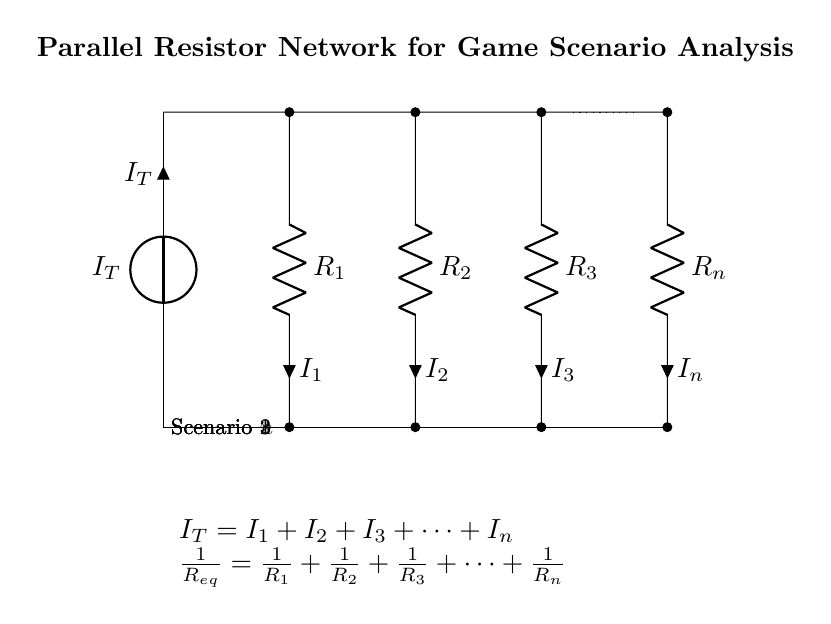What is the total current entering the circuit? The total current \( I_T \) is the sum of the currents through all parallel branches, represented by the equation \( I_T = I_1 + I_2 + I_3 + \cdots + I_n \).
Answer: Total current \( I_T \) What is the equivalent resistance of this parallel network? The equivalent resistance \( R_{eq} \) is calculated by the formula \( \frac{1}{R_{eq}} = \frac{1}{R_1} + \frac{1}{R_2} + \frac{1}{R_3} + \cdots + \frac{1}{R_n} \), indicating how multiple resistors combine in parallel.
Answer: Equivalent resistance \( R_{eq} \) Which resistor contributes to Scenario 2? Resistor \( R_2 \) is associated with Scenario 2, as it is represented in the second branch of the circuit diagram.
Answer: Resistor \( R_2 \) What happens to the current through \( R_3 \) if \( R_3 \) increases significantly? If \( R_3 \) increases, the current \( I_3 \) will decrease because higher resistance results in lower current, following Ohm’s law.
Answer: Current \( I_3 \) decreases What is the relationship between total current and individual branch currents? The total current \( I_T \) is equal to the sum of the individual branch currents, establishing a direct additive relationship in parallel circuits.
Answer: Total current equals sum of branch currents How would the equivalent resistance change if one resistor is removed from the network? Removing a resistor from the parallel network will generally increase the equivalent resistance, as there are fewer parallel paths for the current to flow through.
Answer: Equivalent resistance increases 